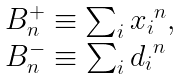Convert formula to latex. <formula><loc_0><loc_0><loc_500><loc_500>\begin{array} { l } B _ { n } ^ { + } \equiv \sum _ { i } { x _ { i } } ^ { n } , \\ B _ { n } ^ { - } \equiv \sum _ { i } { d _ { i } } ^ { n } \end{array}</formula> 